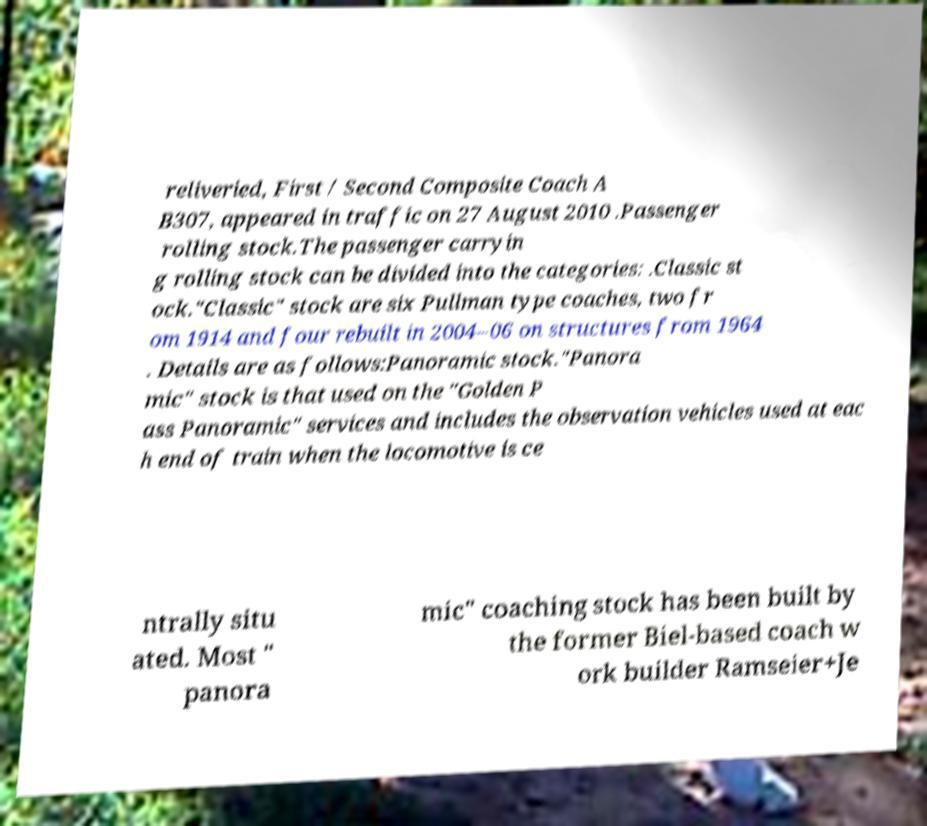There's text embedded in this image that I need extracted. Can you transcribe it verbatim? reliveried, First / Second Composite Coach A B307, appeared in traffic on 27 August 2010 .Passenger rolling stock.The passenger carryin g rolling stock can be divided into the categories: .Classic st ock."Classic" stock are six Pullman type coaches, two fr om 1914 and four rebuilt in 2004–06 on structures from 1964 . Details are as follows:Panoramic stock."Panora mic" stock is that used on the "Golden P ass Panoramic" services and includes the observation vehicles used at eac h end of train when the locomotive is ce ntrally situ ated. Most " panora mic" coaching stock has been built by the former Biel-based coach w ork builder Ramseier+Je 